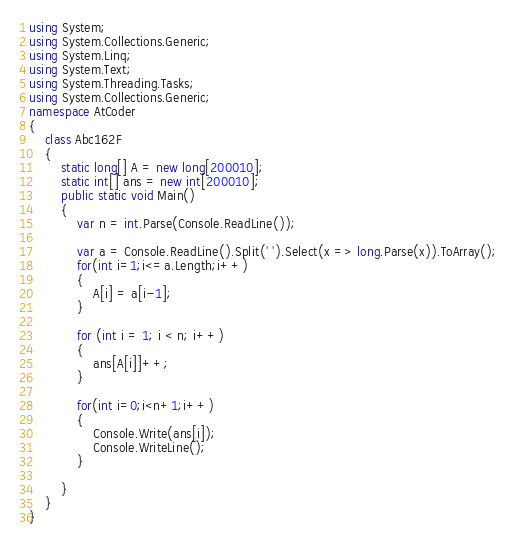<code> <loc_0><loc_0><loc_500><loc_500><_C#_>using System;
using System.Collections.Generic;
using System.Linq;
using System.Text;
using System.Threading.Tasks;
using System.Collections.Generic;
namespace AtCoder
{
    class Abc162F
    {
        static long[] A = new long[200010];
        static int[] ans = new int[200010];
        public static void Main()
        {
            var n = int.Parse(Console.ReadLine());

            var a = Console.ReadLine().Split(' ').Select(x => long.Parse(x)).ToArray();
            for(int i=1;i<=a.Length;i++)
            {
                A[i] = a[i-1];
            }

            for (int i = 1; i < n; i++)
            {
                ans[A[i]]++;
            }

            for(int i=0;i<n+1;i++)
            {
                Console.Write(ans[i]);
                Console.WriteLine();
            }

        }
    }
}
</code> 